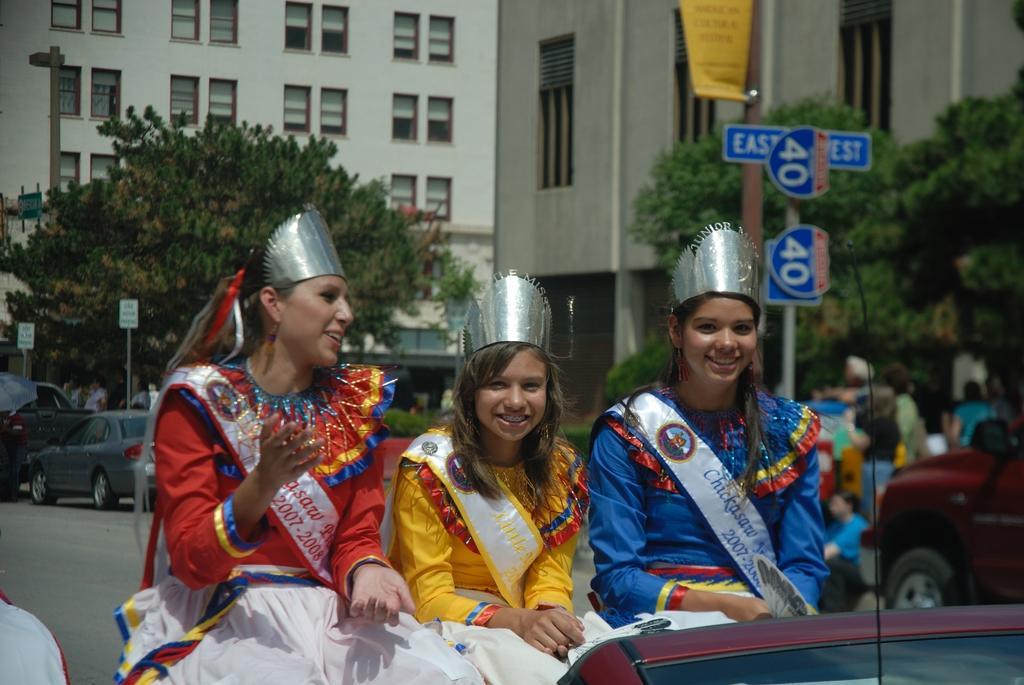Please provide a concise description of this image. The image is outside of the city. In the image there are three woman sitting on car, on rights side we can see group of people,hoardings,trees,buildings,windows. On left side there are few cars and hoardings, in background there is a white color building. 